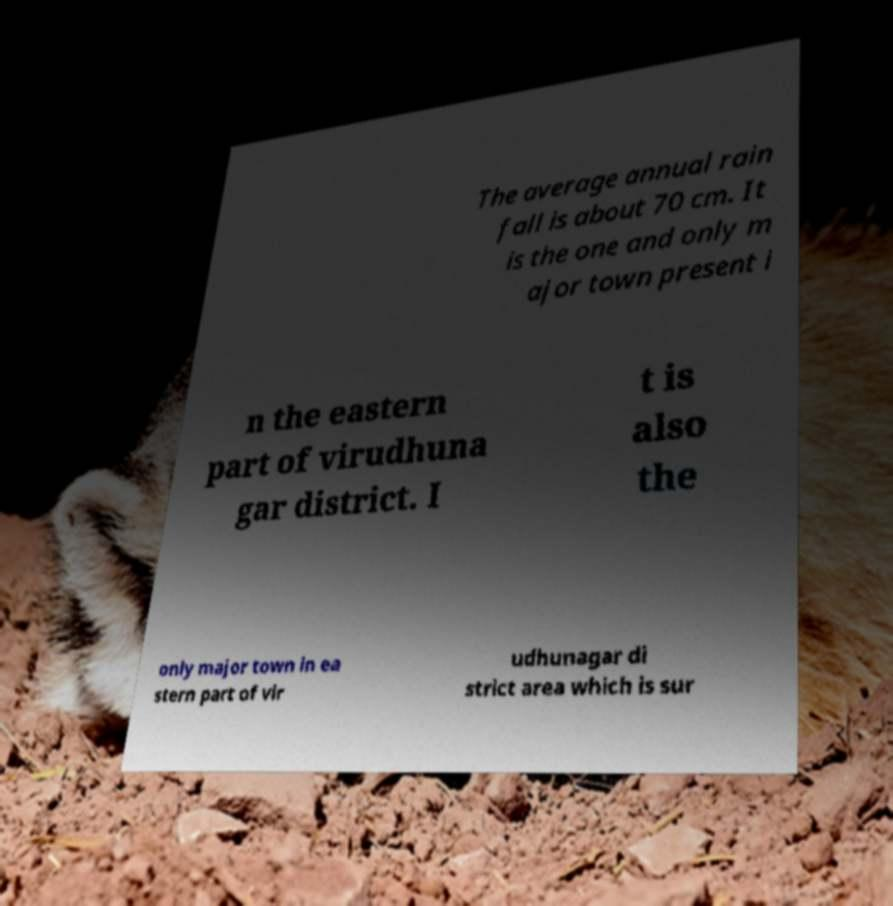Can you accurately transcribe the text from the provided image for me? The average annual rain fall is about 70 cm. It is the one and only m ajor town present i n the eastern part of virudhuna gar district. I t is also the only major town in ea stern part of vir udhunagar di strict area which is sur 